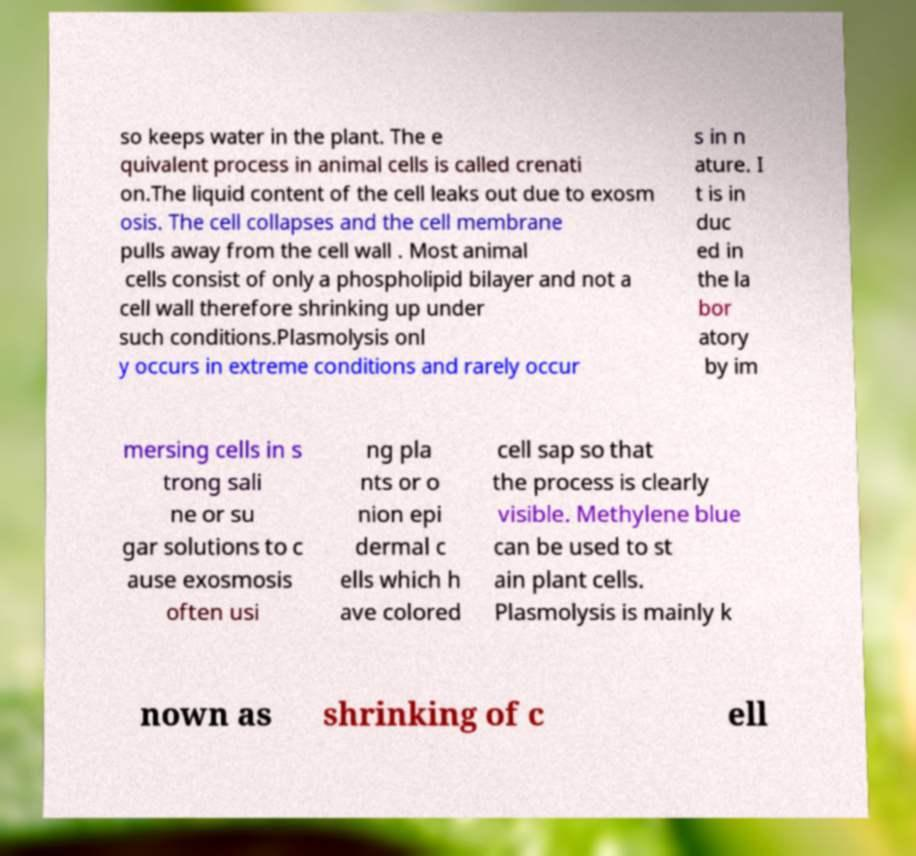What messages or text are displayed in this image? I need them in a readable, typed format. so keeps water in the plant. The e quivalent process in animal cells is called crenati on.The liquid content of the cell leaks out due to exosm osis. The cell collapses and the cell membrane pulls away from the cell wall . Most animal cells consist of only a phospholipid bilayer and not a cell wall therefore shrinking up under such conditions.Plasmolysis onl y occurs in extreme conditions and rarely occur s in n ature. I t is in duc ed in the la bor atory by im mersing cells in s trong sali ne or su gar solutions to c ause exosmosis often usi ng pla nts or o nion epi dermal c ells which h ave colored cell sap so that the process is clearly visible. Methylene blue can be used to st ain plant cells. Plasmolysis is mainly k nown as shrinking of c ell 